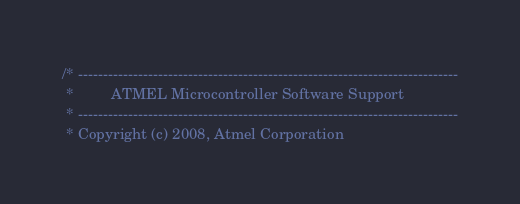<code> <loc_0><loc_0><loc_500><loc_500><_C_>/* ----------------------------------------------------------------------------
 *         ATMEL Microcontroller Software Support 
 * ----------------------------------------------------------------------------
 * Copyright (c) 2008, Atmel Corporation</code> 